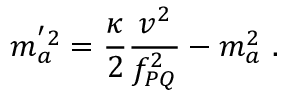<formula> <loc_0><loc_0><loc_500><loc_500>m _ { a } ^ { ^ { \prime } 2 } = { \frac { \kappa } { 2 } } { \frac { v ^ { 2 } } { f _ { P Q } ^ { 2 } } } - m _ { a } ^ { 2 } .</formula> 